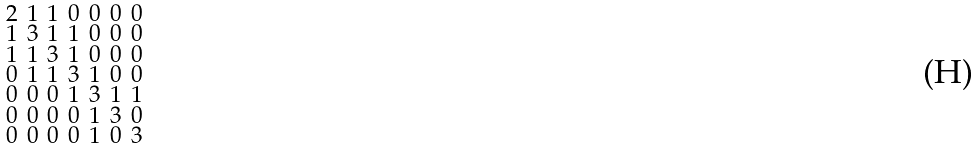<formula> <loc_0><loc_0><loc_500><loc_500>\begin{smallmatrix} 2 & 1 & 1 & 0 & 0 & 0 & 0 \\ 1 & 3 & 1 & 1 & 0 & 0 & 0 \\ 1 & 1 & 3 & 1 & 0 & 0 & 0 \\ 0 & 1 & 1 & 3 & 1 & 0 & 0 \\ 0 & 0 & 0 & 1 & 3 & 1 & 1 \\ 0 & 0 & 0 & 0 & 1 & 3 & 0 \\ 0 & 0 & 0 & 0 & 1 & 0 & 3 \end{smallmatrix}</formula> 